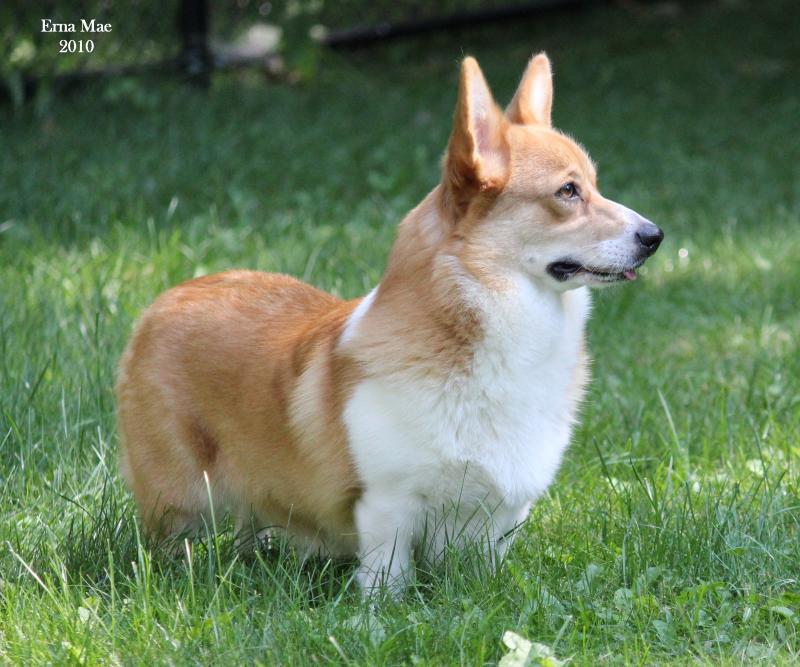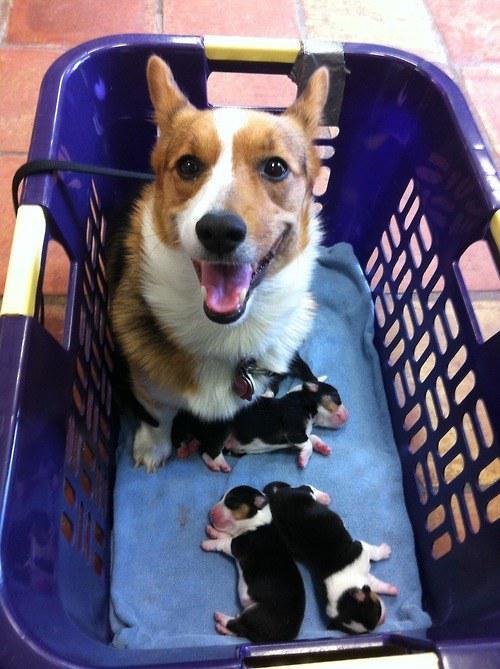The first image is the image on the left, the second image is the image on the right. Analyze the images presented: Is the assertion "There is 1 or more corgi's showing it's tongue." valid? Answer yes or no. Yes. 